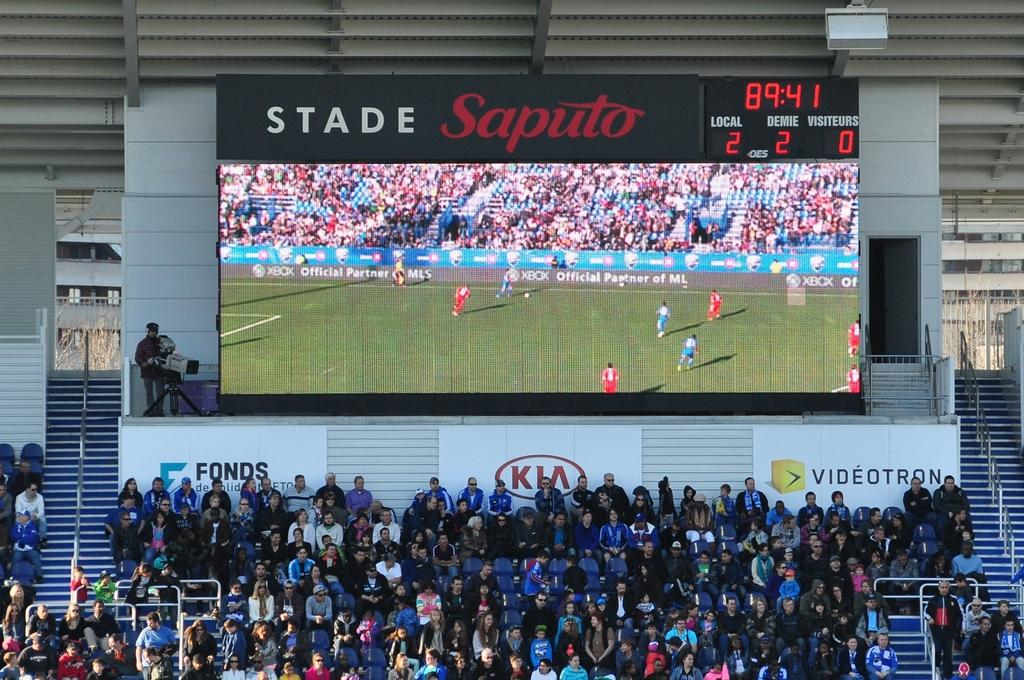<image>
Provide a brief description of the given image. Many people are sitting at a stadium with the score board above them showing the soccer game and says Stand Saputo. 